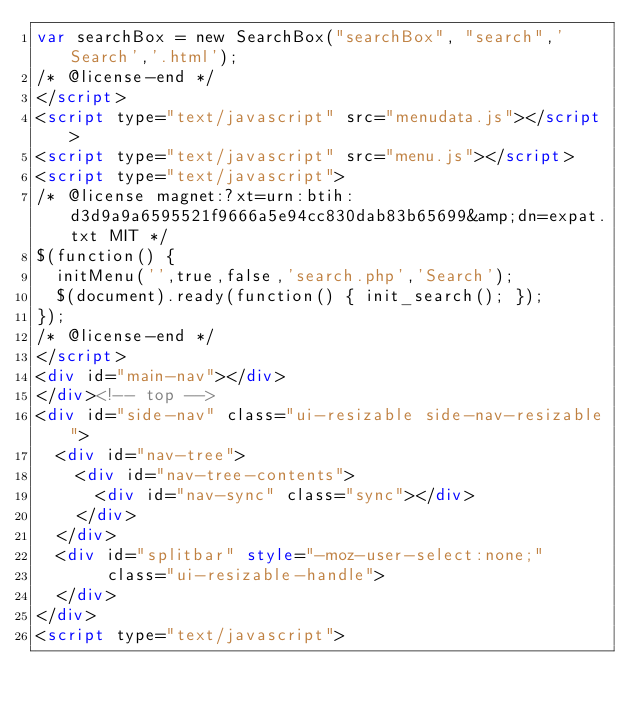Convert code to text. <code><loc_0><loc_0><loc_500><loc_500><_HTML_>var searchBox = new SearchBox("searchBox", "search",'Search','.html');
/* @license-end */
</script>
<script type="text/javascript" src="menudata.js"></script>
<script type="text/javascript" src="menu.js"></script>
<script type="text/javascript">
/* @license magnet:?xt=urn:btih:d3d9a9a6595521f9666a5e94cc830dab83b65699&amp;dn=expat.txt MIT */
$(function() {
  initMenu('',true,false,'search.php','Search');
  $(document).ready(function() { init_search(); });
});
/* @license-end */
</script>
<div id="main-nav"></div>
</div><!-- top -->
<div id="side-nav" class="ui-resizable side-nav-resizable">
  <div id="nav-tree">
    <div id="nav-tree-contents">
      <div id="nav-sync" class="sync"></div>
    </div>
  </div>
  <div id="splitbar" style="-moz-user-select:none;" 
       class="ui-resizable-handle">
  </div>
</div>
<script type="text/javascript"></code> 